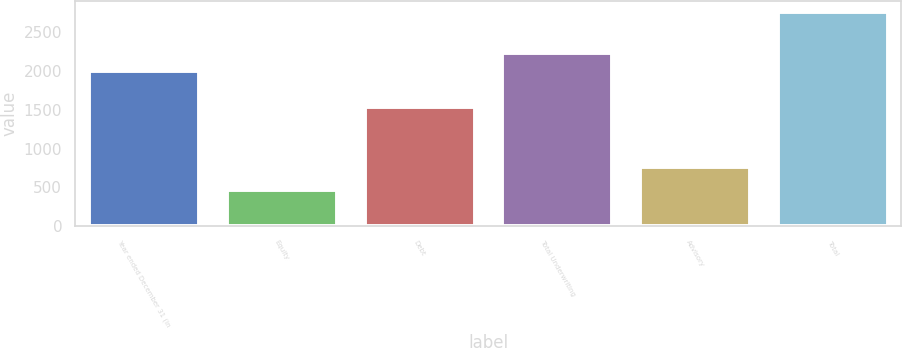Convert chart to OTSL. <chart><loc_0><loc_0><loc_500><loc_500><bar_chart><fcel>Year ended December 31 (in<fcel>Equity<fcel>Debt<fcel>Total Underwriting<fcel>Advisory<fcel>Total<nl><fcel>2002<fcel>464<fcel>1543<fcel>2231.9<fcel>756<fcel>2763<nl></chart> 